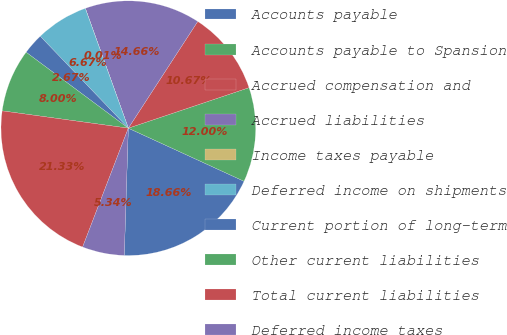Convert chart to OTSL. <chart><loc_0><loc_0><loc_500><loc_500><pie_chart><fcel>Accounts payable<fcel>Accounts payable to Spansion<fcel>Accrued compensation and<fcel>Accrued liabilities<fcel>Income taxes payable<fcel>Deferred income on shipments<fcel>Current portion of long-term<fcel>Other current liabilities<fcel>Total current liabilities<fcel>Deferred income taxes<nl><fcel>18.66%<fcel>12.0%<fcel>10.67%<fcel>14.66%<fcel>0.01%<fcel>6.67%<fcel>2.67%<fcel>8.0%<fcel>21.33%<fcel>5.34%<nl></chart> 